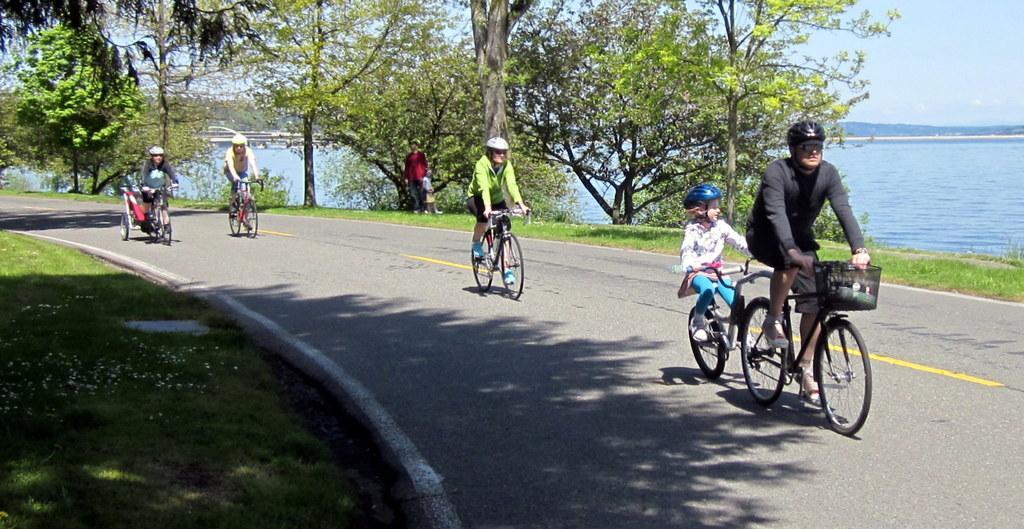Please provide a concise description of this image. In this image there are group of people who are sitting on a cycle and they are riding a cycle and on the top of the right corner there is sky and in the middle there is a river and on the bottom there is a grass and on the left side of the bottom there is grass and on the top there are trees and in the middle of the image there is one person who is standing. 